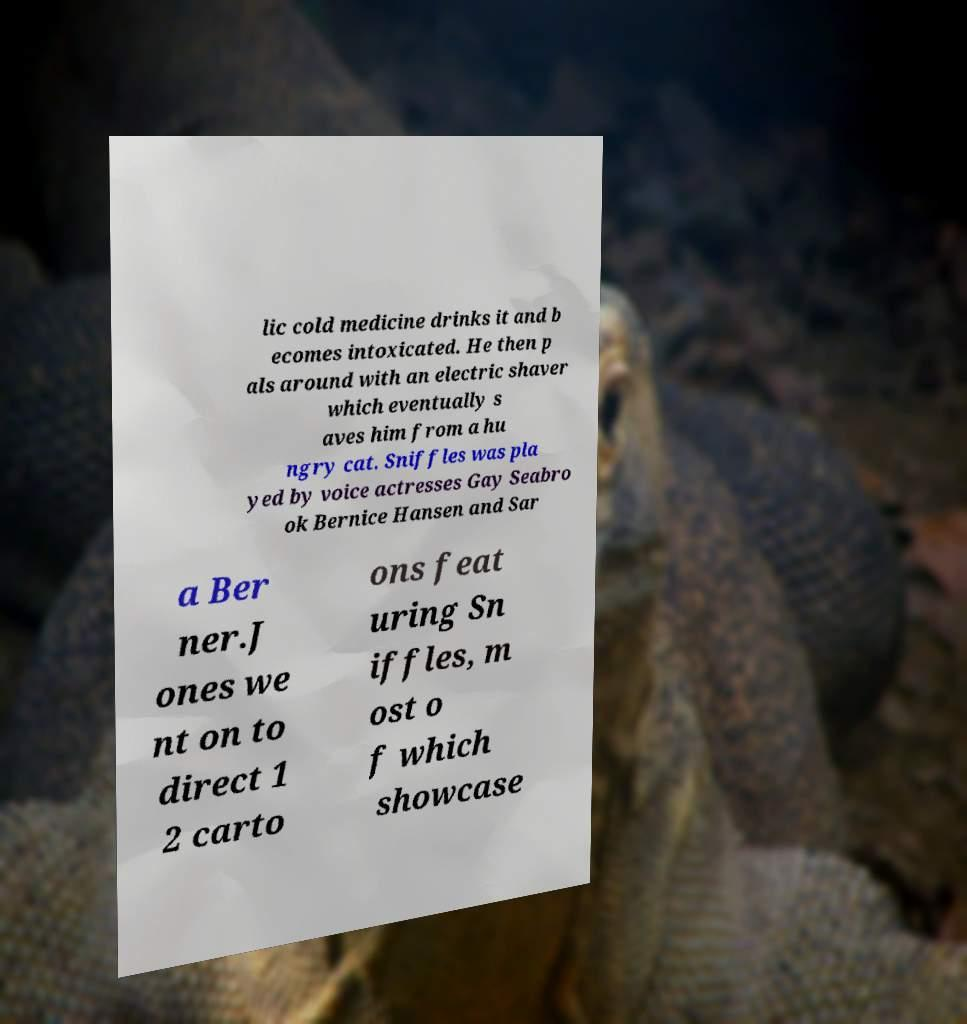Can you read and provide the text displayed in the image?This photo seems to have some interesting text. Can you extract and type it out for me? lic cold medicine drinks it and b ecomes intoxicated. He then p als around with an electric shaver which eventually s aves him from a hu ngry cat. Sniffles was pla yed by voice actresses Gay Seabro ok Bernice Hansen and Sar a Ber ner.J ones we nt on to direct 1 2 carto ons feat uring Sn iffles, m ost o f which showcase 